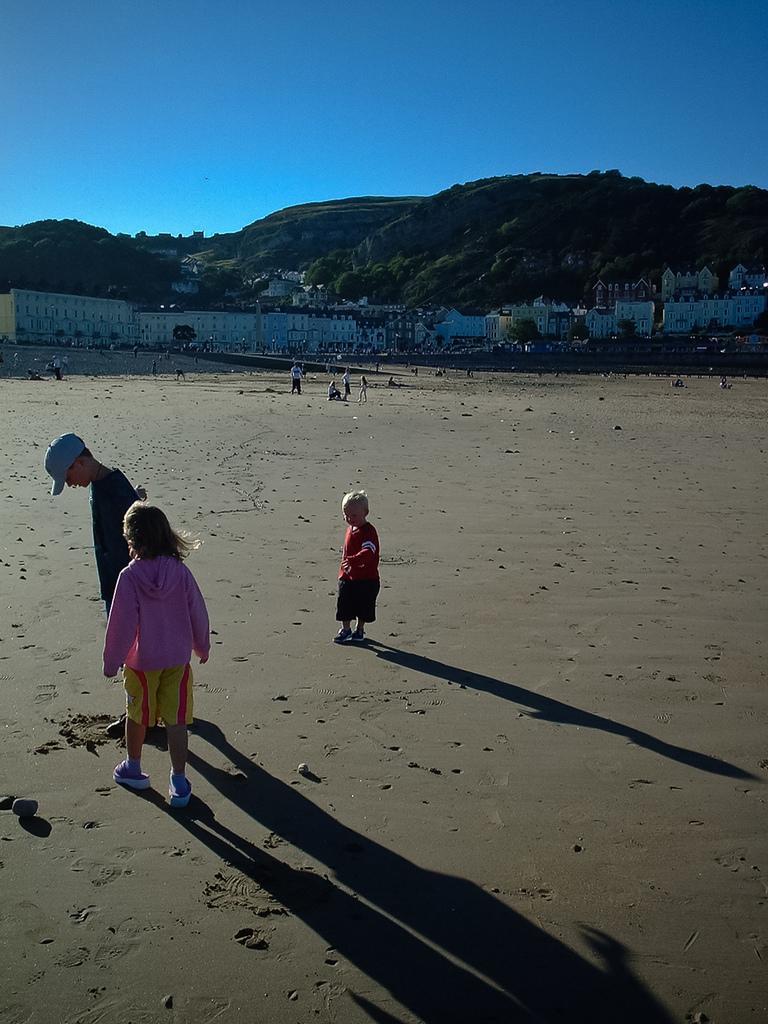In one or two sentences, can you explain what this image depicts? In this picture we can see there are some people standing on the path and behind the people there are buildings, trees, hills and the sky. 